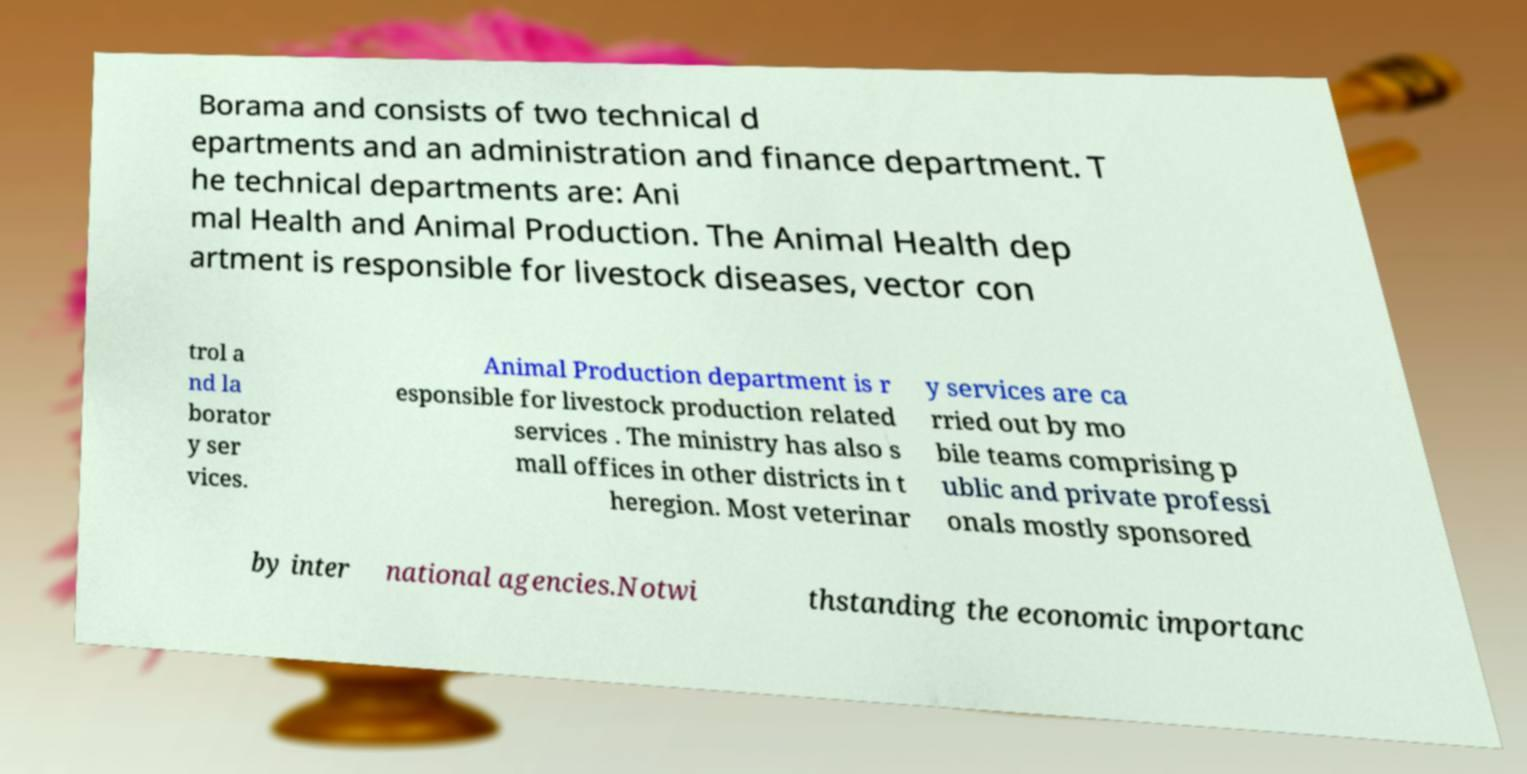Can you accurately transcribe the text from the provided image for me? Borama and consists of two technical d epartments and an administration and finance department. T he technical departments are: Ani mal Health and Animal Production. The Animal Health dep artment is responsible for livestock diseases, vector con trol a nd la borator y ser vices. Animal Production department is r esponsible for livestock production related services . The ministry has also s mall offices in other districts in t heregion. Most veterinar y services are ca rried out by mo bile teams comprising p ublic and private professi onals mostly sponsored by inter national agencies.Notwi thstanding the economic importanc 